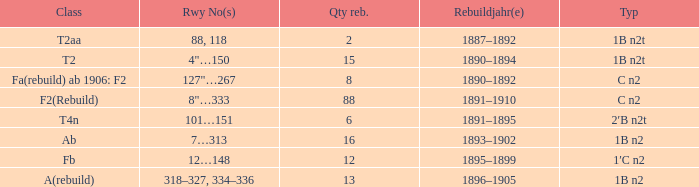What is the total of quantity rebuilt if the type is 1B N2T and the railway number is 88, 118? 1.0. Give me the full table as a dictionary. {'header': ['Class', 'Rwy No(s)', 'Qty reb.', 'Rebuildjahr(e)', 'Typ'], 'rows': [['T2aa', '88, 118', '2', '1887–1892', '1B n2t'], ['T2', '4"…150', '15', '1890–1894', '1B n2t'], ['Fa(rebuild) ab 1906: F2', '127"…267', '8', '1890–1892', 'C n2'], ['F2(Rebuild)', '8"…333', '88', '1891–1910', 'C n2'], ['T4n', '101…151', '6', '1891–1895', '2′B n2t'], ['Ab', '7…313', '16', '1893–1902', '1B n2'], ['Fb', '12…148', '12', '1895–1899', '1′C n2'], ['A(rebuild)', '318–327, 334–336', '13', '1896–1905', '1B n2']]} 